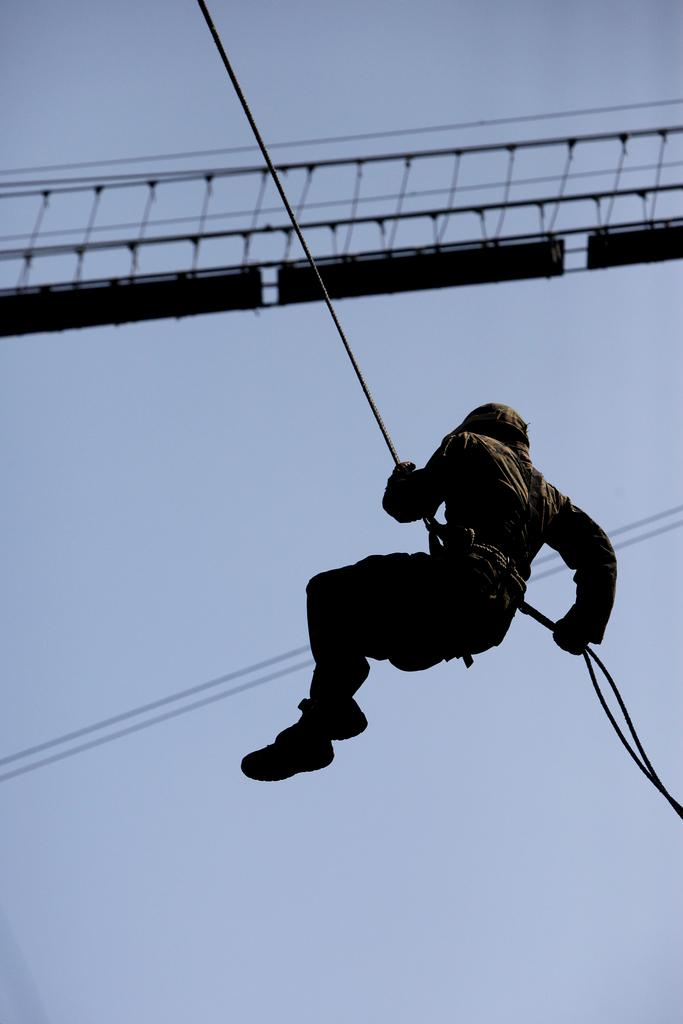What is the person in the image doing? The person in the image is hanging with a rope. What else can be seen in the image besides the person? There are cables visible in the image, as well as a wooden bridge. What is visible in the background of the image? The sky is visible in the background of the image. What type of mine can be seen in the image? There is no mine present in the image; it features a person hanging with a rope, cables, a wooden bridge, and the sky in the background. 